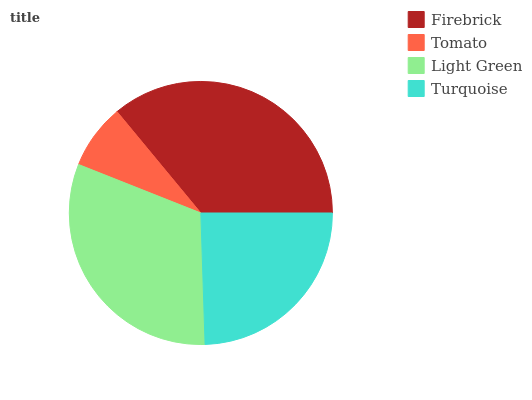Is Tomato the minimum?
Answer yes or no. Yes. Is Firebrick the maximum?
Answer yes or no. Yes. Is Light Green the minimum?
Answer yes or no. No. Is Light Green the maximum?
Answer yes or no. No. Is Light Green greater than Tomato?
Answer yes or no. Yes. Is Tomato less than Light Green?
Answer yes or no. Yes. Is Tomato greater than Light Green?
Answer yes or no. No. Is Light Green less than Tomato?
Answer yes or no. No. Is Light Green the high median?
Answer yes or no. Yes. Is Turquoise the low median?
Answer yes or no. Yes. Is Firebrick the high median?
Answer yes or no. No. Is Tomato the low median?
Answer yes or no. No. 